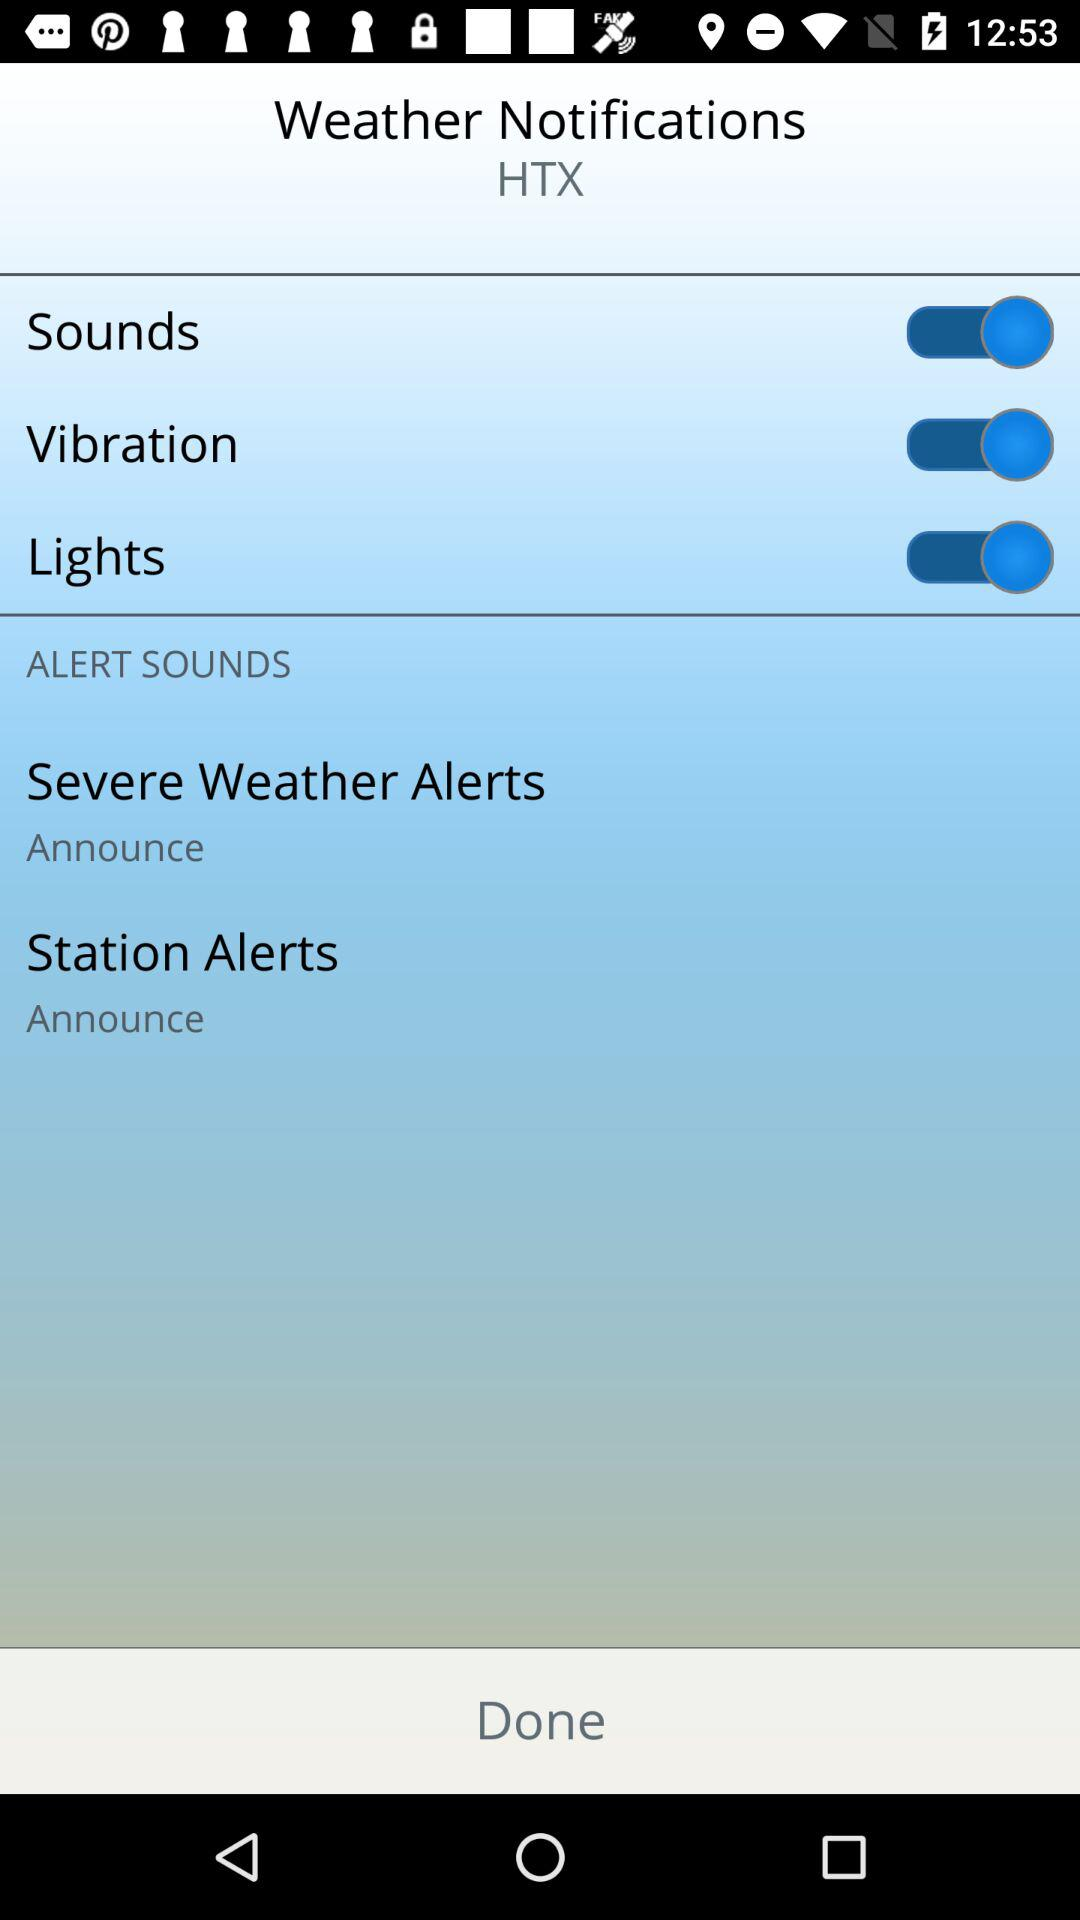How many more alert sounds can be customized than station alerts?
Answer the question using a single word or phrase. 1 